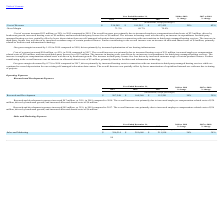According to Zendesk's financial document, What was the increase in marketing program costs from 2017 to 2018? Based on the financial document, the answer is $10 million. Also, can you calculate: What is the difference between the increase sales and marketing expenses from 2018 to 2019 and 2017 to 2018? Based on the calculation: 105 - 80 , the result is 25 (in millions). The key data points involved are: 105, 80. Also, What is the driver for an increase in marketing program costs from 2018 to 2019? Based on the financial document, the answer is The increase in marketing program costs was driven by increased volume of advertising activities.. Also, can you calculate: What is the percentage increase in sales and marketing expenses from 2017 to 2019? To answer this question, I need to perform calculations using the financial data. The calculation is: (396,514 - 211,918) / 211,918 , which equals 87.11 (percentage). This is based on the information: "Sales and Marketing $ 396,514 $ 291,668 $ 211,918 36% 38% Sales and Marketing $ 396,514 $ 291,668 $ 211,918 36% 38%..." The key data points involved are: 211,918, 396,514. Also, What was the percentage increase in sales and marketing expenses from 2018 to 2019? According to the financial document, 36%. The relevant text states: "Sales and Marketing $ 396,514 $ 291,668 $ 211,918 36% 38%..." Also, can you calculate: What was the increase in sales and marketing expenses from 2017 to 2019? Based on the calculation: 80 + 105 , the result is 185 (in millions). The key data points involved are: 105, 80. 